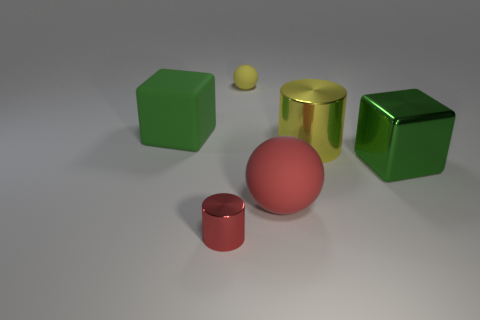Is the tiny red thing the same shape as the large yellow metallic object? The smaller red object appears to be a cylinder, similar to the larger yellow object, which is also cylindrical in shape. The similarity in shape suggests a common geometric form, although their sizes and colors differ. 